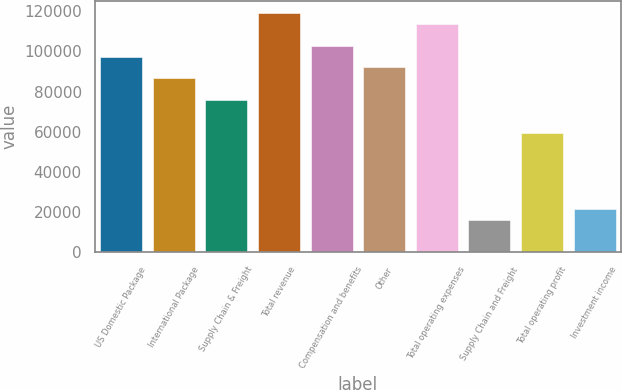Convert chart to OTSL. <chart><loc_0><loc_0><loc_500><loc_500><bar_chart><fcel>US Domestic Package<fcel>International Package<fcel>Supply Chain & Freight<fcel>Total revenue<fcel>Compensation and benefits<fcel>Other<fcel>Total operating expenses<fcel>Supply Chain and Freight<fcel>Total operating profit<fcel>Investment income<nl><fcel>97428<fcel>86602.8<fcel>75777.5<fcel>119078<fcel>102841<fcel>92015.4<fcel>113666<fcel>16238.7<fcel>59539.7<fcel>21651.3<nl></chart> 